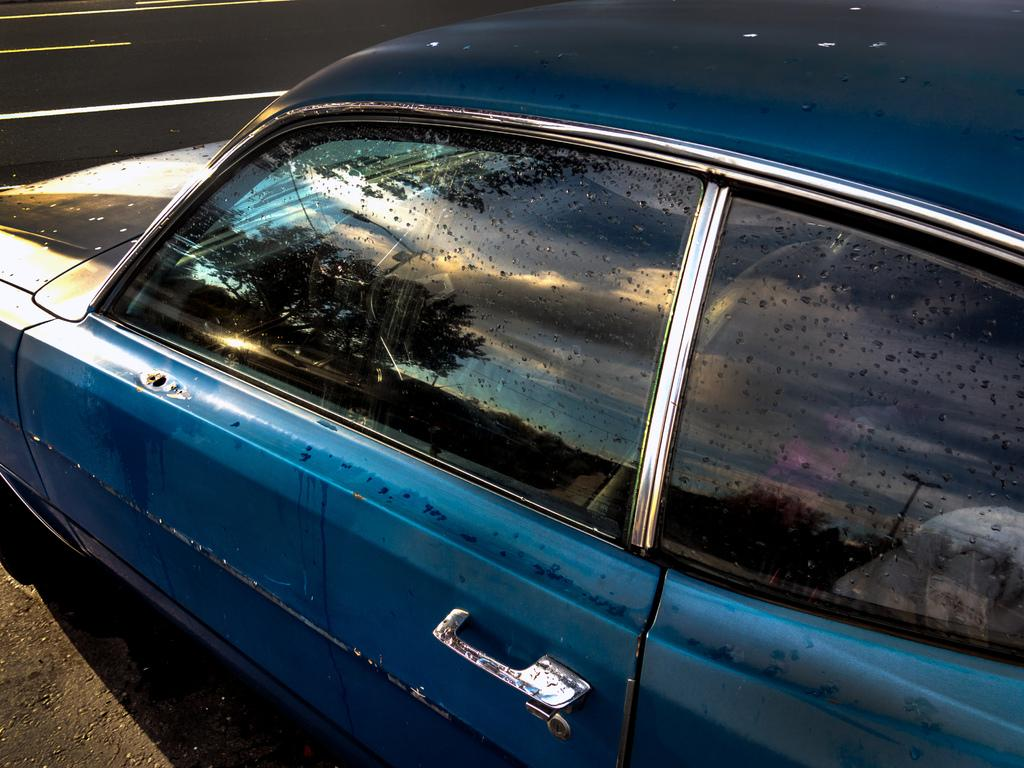What is the main subject in the foreground of the image? There is a car in the foreground of the image. What can be seen in the background of the image? Trees are visible in the image. What feature of the car is reflecting the sky? The sky is reflected in the glass of the car. What type of lunch is being served on the hood of the car in the image? There is no lunch or any food items visible on the hood of the car in the image. 